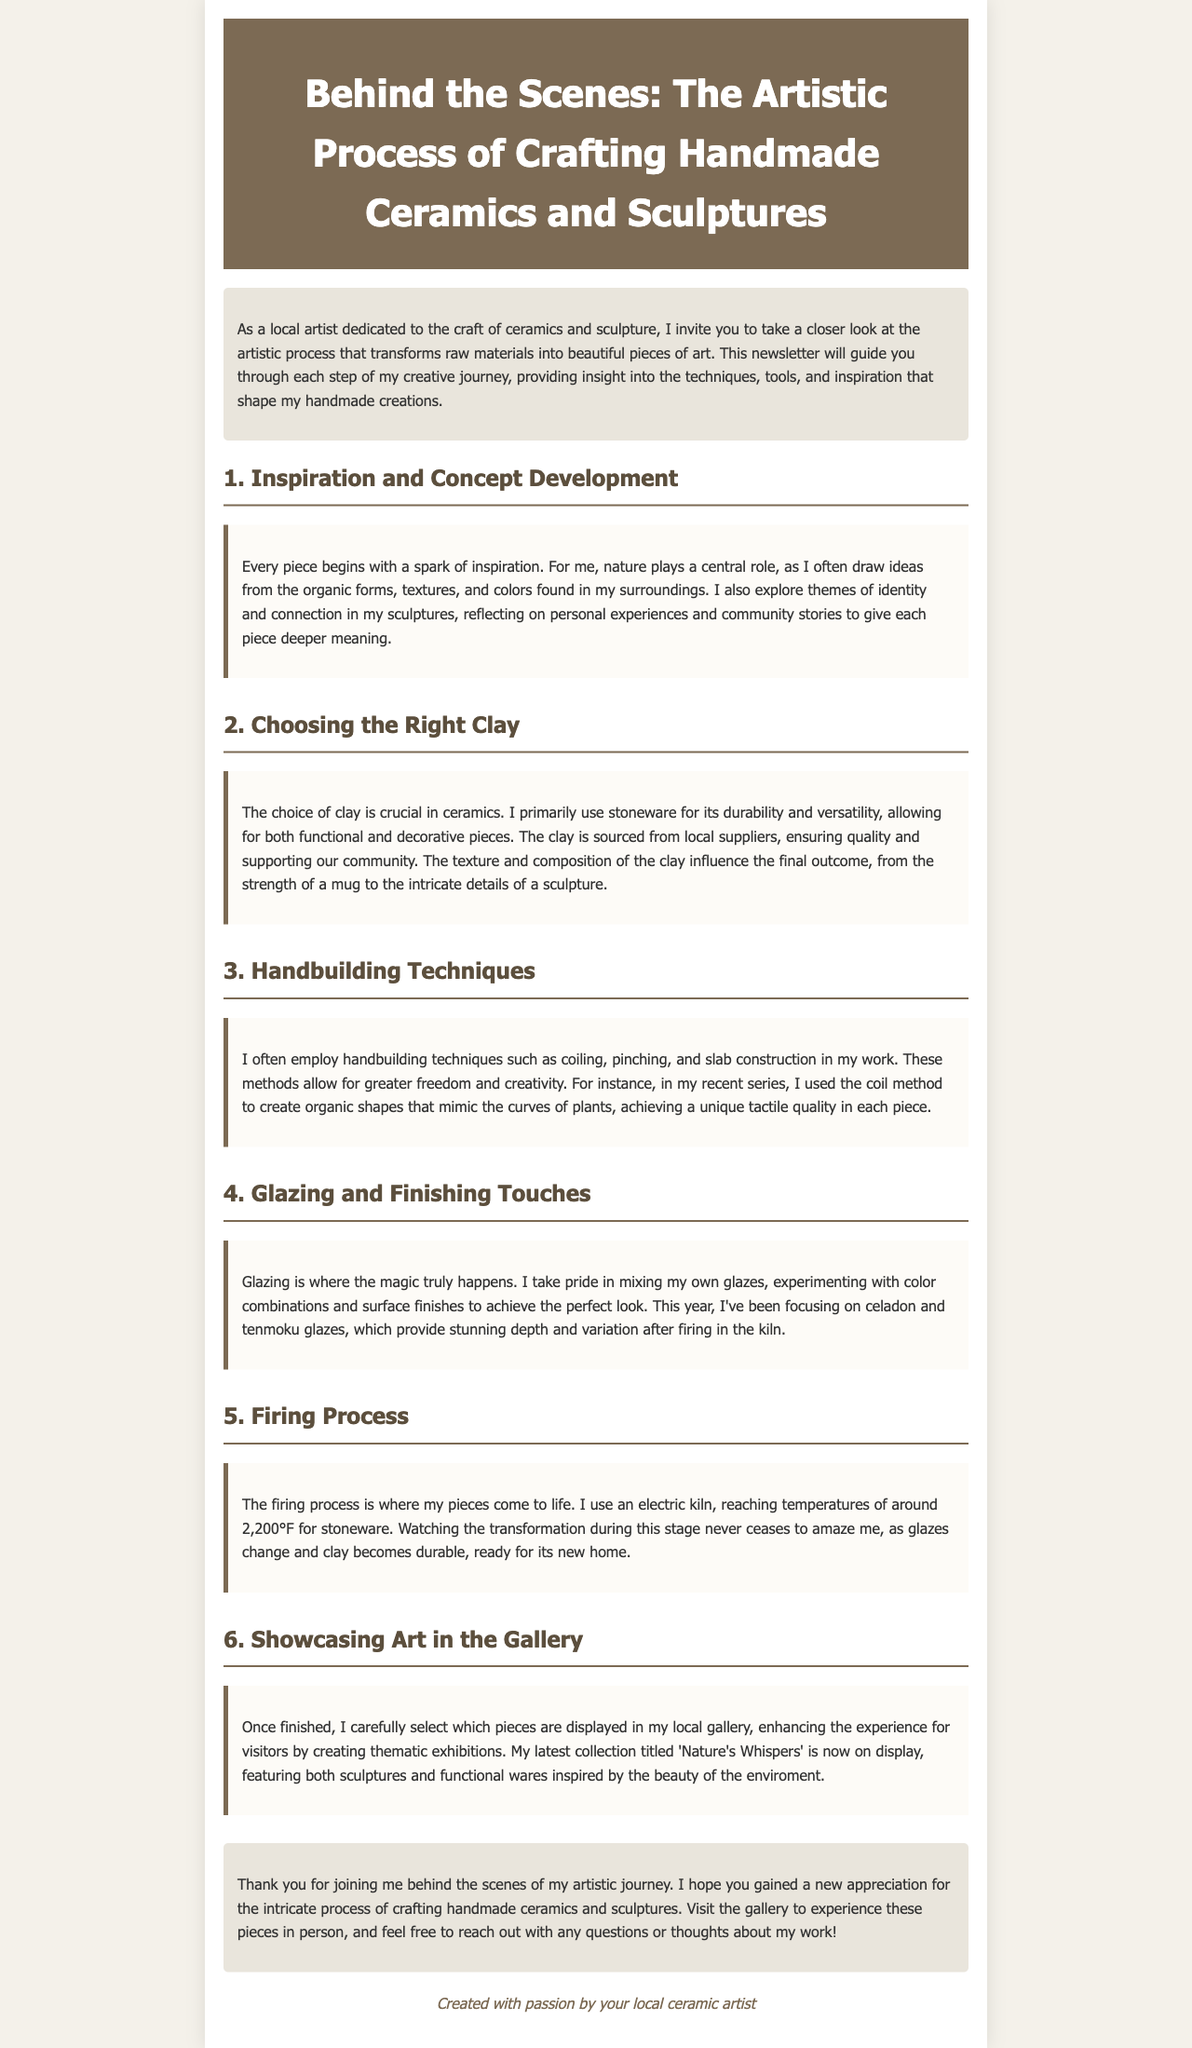What role does nature play in the inspiration for the artworks? Nature plays a central role, as the artist draws ideas from organic forms, textures, and colors found in surroundings.
Answer: Central role What kind of clay is primarily used by the artist? The artist primarily uses stoneware for its durability and versatility.
Answer: Stoneware Which handbuilding technique is mentioned in relation to creating organic shapes? The coil method is mentioned for creating organic shapes that mimic the curves of plants.
Answer: Coil method What two types of glazes has the artist been focusing on this year? The artist has been focusing on celadon and tenmoku glazes.
Answer: Celadon and tenmoku What is the title of the latest collection displayed in the gallery? The latest collection is titled 'Nature's Whispers'.
Answer: Nature's Whispers At what temperature does the firing process reach for stoneware? The firing process reaches temperatures of around 2,200°F for stoneware.
Answer: 2,200°F What is the purpose of selecting pieces for thematic exhibitions in the gallery? The purpose is to enhance the experience for visitors.
Answer: Enhance the experience How does the artist describe the transformation during the firing process? The artist describes it as amazing, as glazes change and clay becomes durable.
Answer: Amazing What was the main theme explored in the artist's sculptures? The main theme explored is identity and connection.
Answer: Identity and connection 